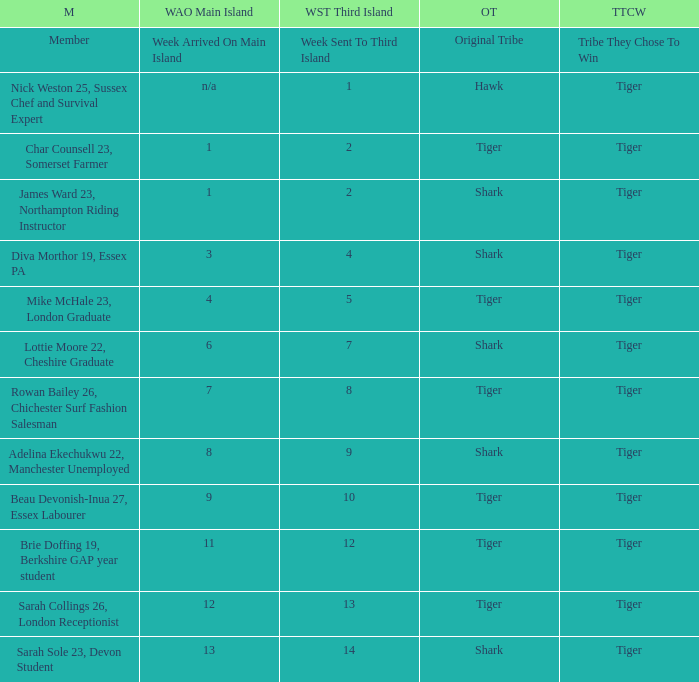Who was sent to the third island in week 1? Nick Weston 25, Sussex Chef and Survival Expert. 